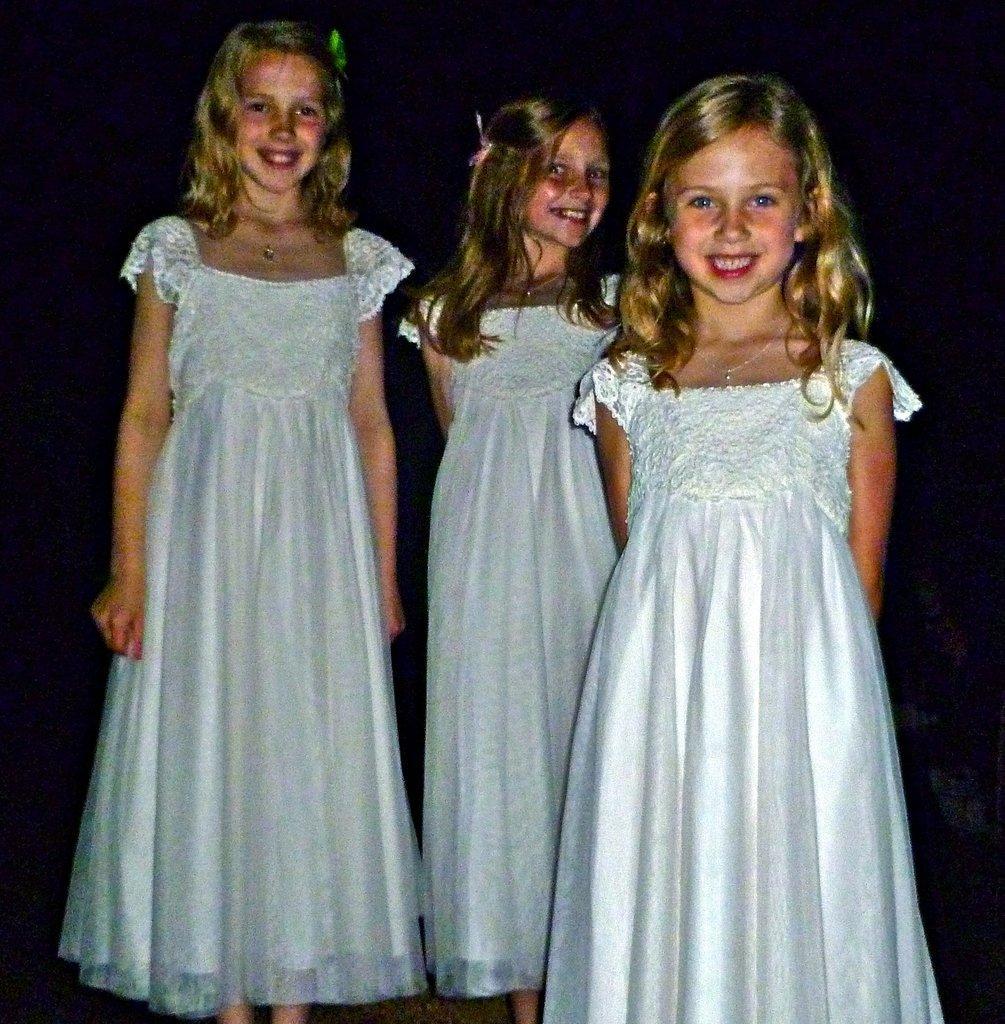Please provide a concise description of this image. In this picture we can see three kids standing and smiling, they wore white color dresses, we can see a dark background here. 